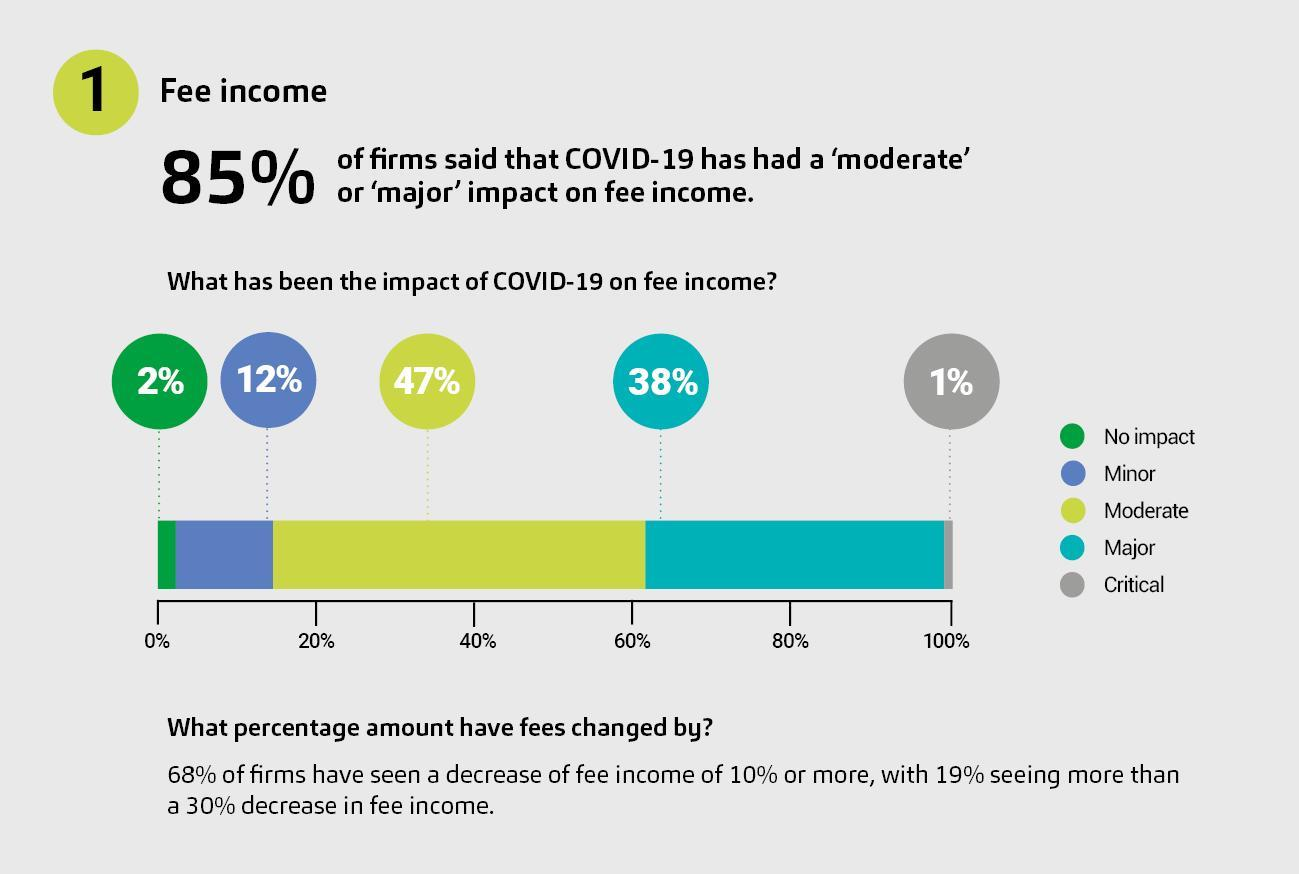On what percentage of firms did covid-19 have a major impact?
Answer the question with a short phrase. 38% On what percentage of firms did covid-19 have a minor impact? 12% On what percentage of firms did covid-19 have a moderate impact? 47% What percentage of firms had 'major' or 'critical' impact on fee income, due to covid-19? 39% By what percentage, were the firm's having a 'major impact' higher than those having a 'critical impact'? 37% By what percent, were the firms having a 'minor impact' on fee income, higher than those having 'no impact'? 10% What colour is used to indicate 'no impact' - yellow, blue, white or green? Green On what percentage of firms, did covid-19 have a critical impact? 1% On what percentage of firms did covid-19 have 'no impact'? 2% What percentage of firms had 'no impact' or 'minor impact' on fee income, due to covid-19? 14% 